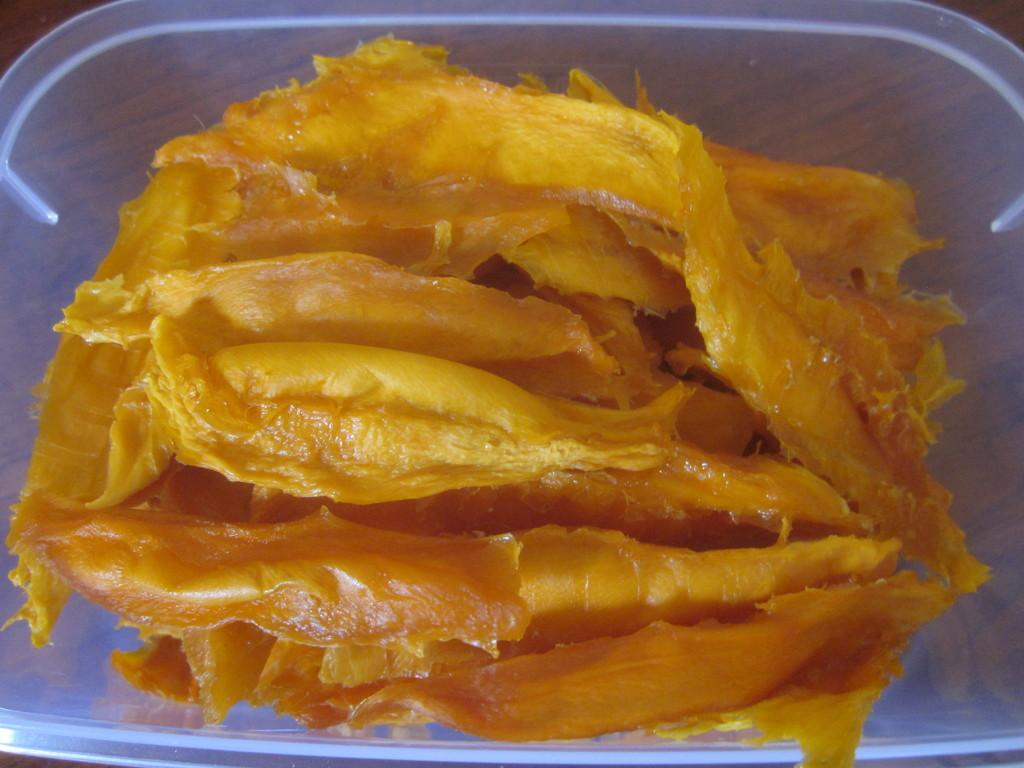What is in the bowl that is visible in the image? There is a bowl with food in the image. What type of surface is the bowl placed on? The wooden surface is present in the image. What mathematical operation is being performed on the food in the image? There is no indication of any mathematical operation being performed on the food in the image. 